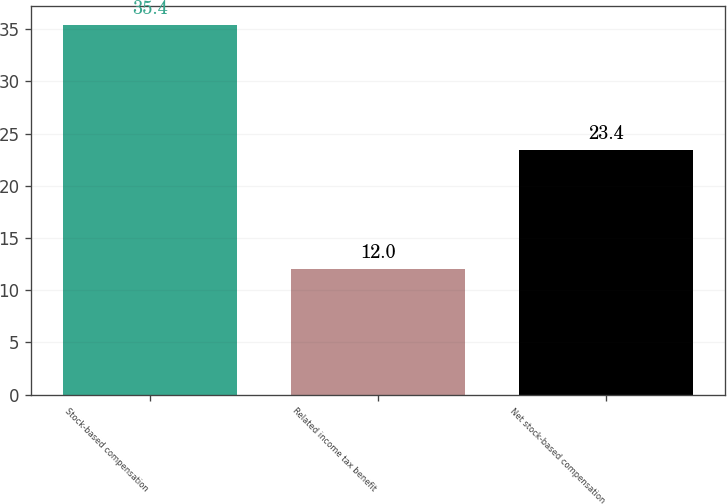Convert chart. <chart><loc_0><loc_0><loc_500><loc_500><bar_chart><fcel>Stock-based compensation<fcel>Related income tax benefit<fcel>Net stock-based compensation<nl><fcel>35.4<fcel>12<fcel>23.4<nl></chart> 